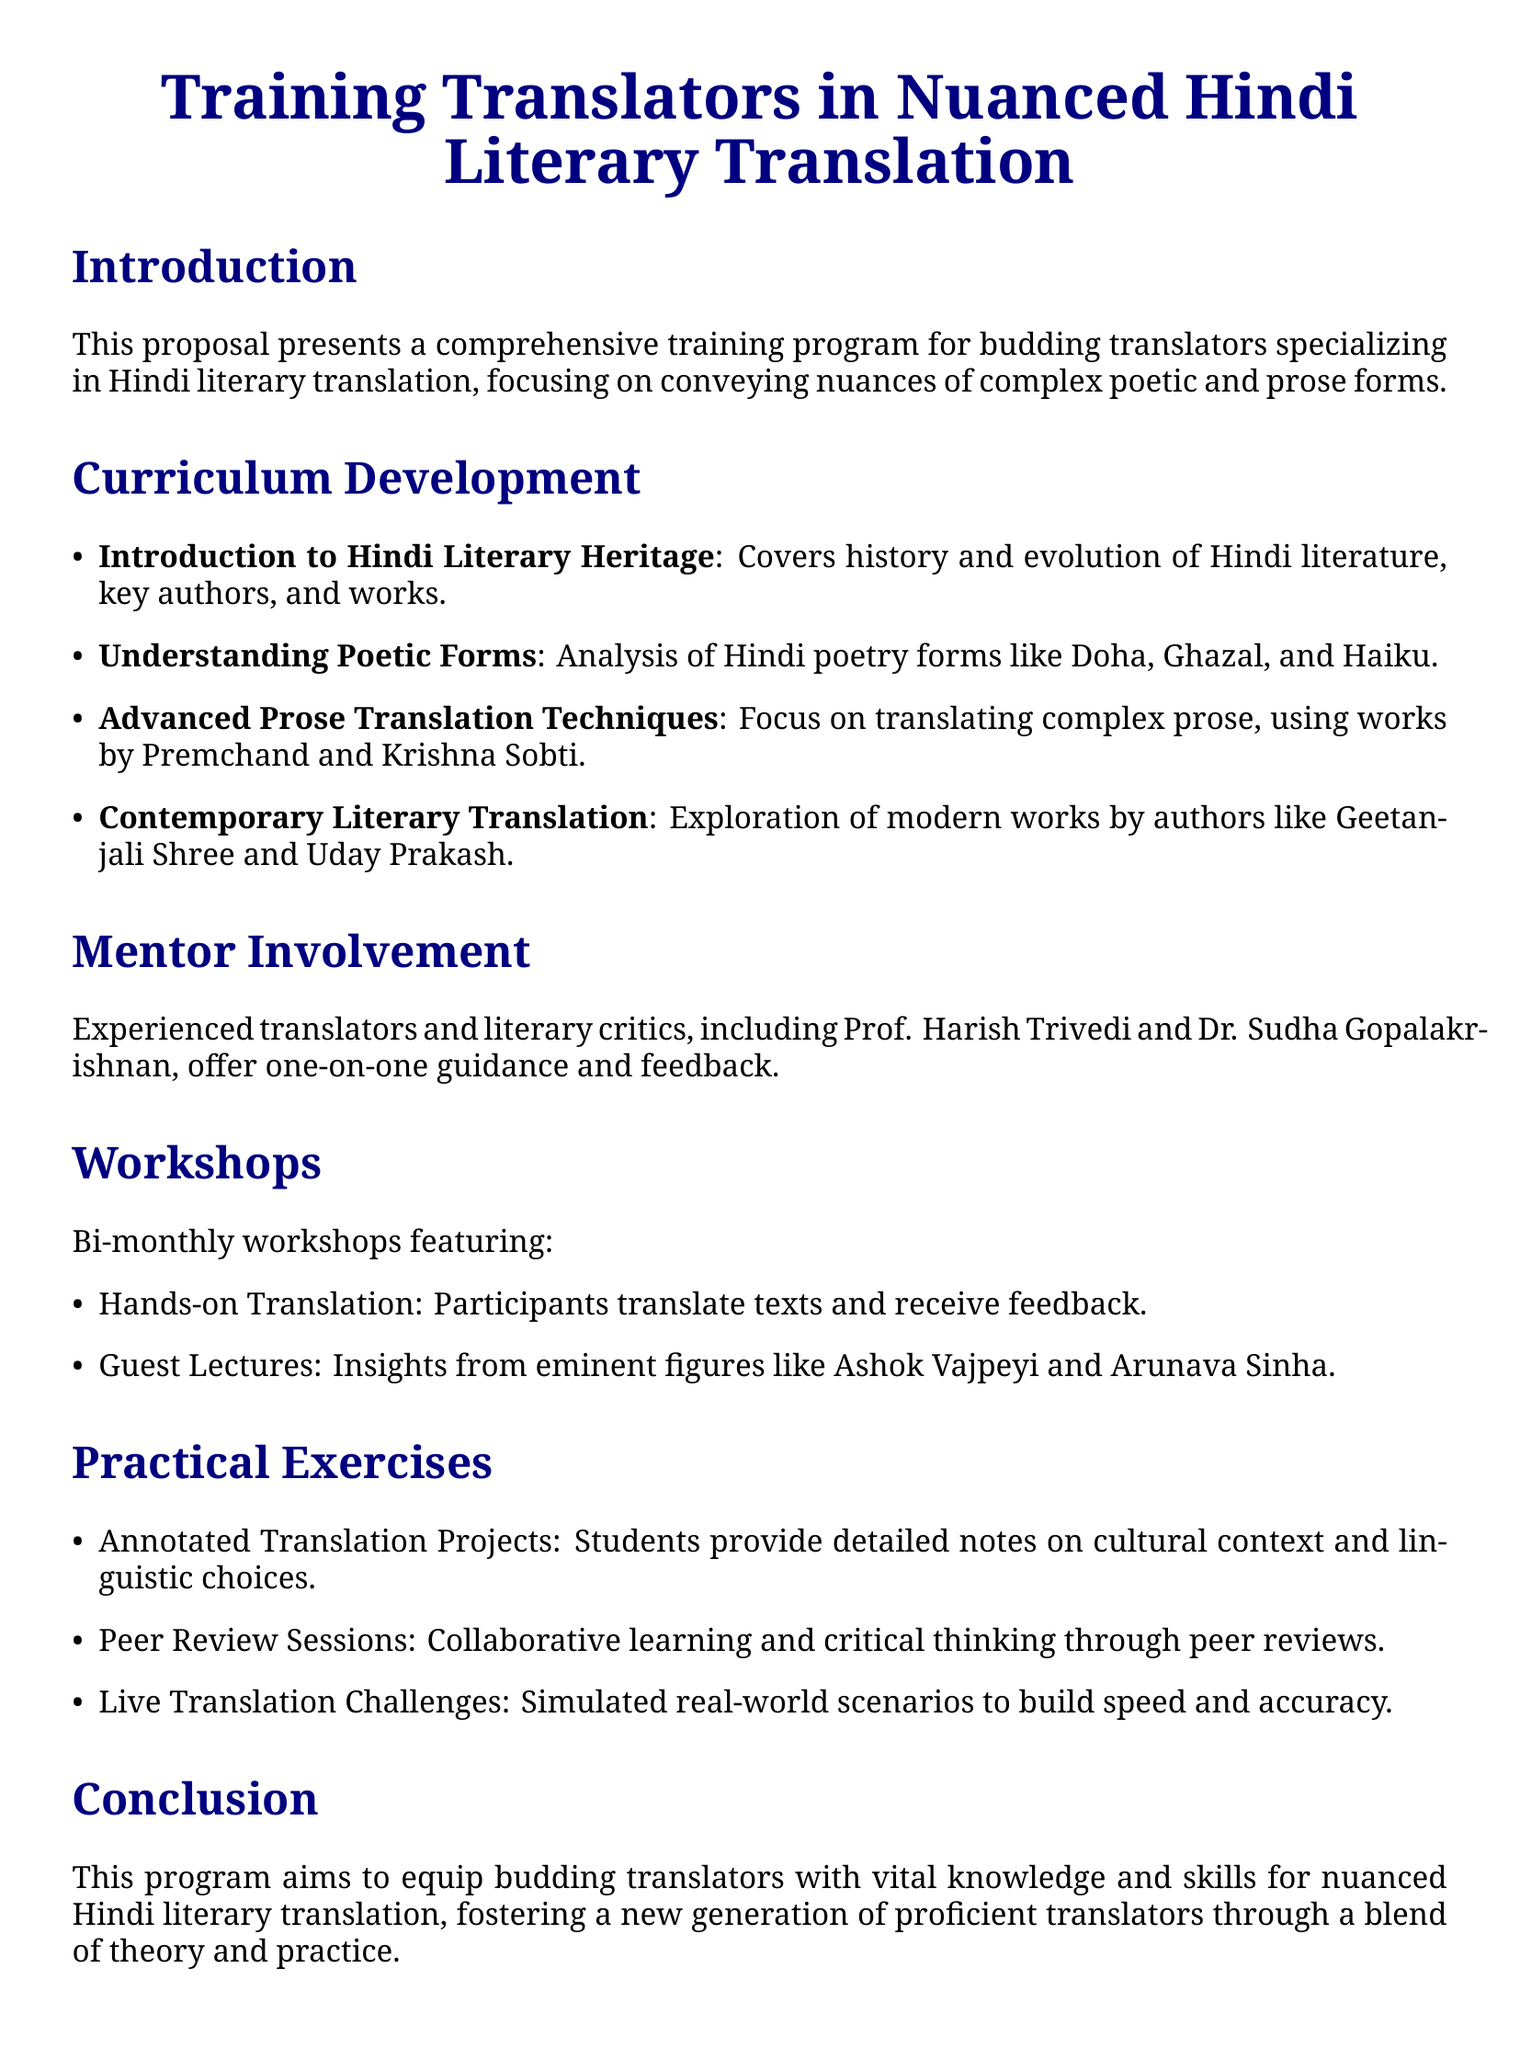What is the title of the proposal? The title of the proposal is explicitly stated at the beginning of the document.
Answer: Training Translators in Nuanced Hindi Literary Translation Who offers guidance in the mentor section? The document lists experienced translators and critics who provide mentorship.
Answer: Prof. Harish Trivedi and Dr. Sudha Gopalakrishnan What genre of works will participants analyze in the curriculum? The curriculum focuses on specific types of literature for translation.
Answer: Hindi poetry and prose How often are the workshops held? The document specifies the frequency of the workshops as outlined in the workshops section.
Answer: Bi-monthly What is one type of practical exercise mentioned? The document describes various exercises designed for practical training.
Answer: Annotated Translation Projects Which modern authors are explored in the curriculum? The proposal lists contemporary authors whose works will be studied.
Answer: Geetanjali Shree and Uday Prakash What is the goal of the training program? The conclusion summarizes the overall aim of the proposal.
Answer: Equip budding translators What is emphasized in the "Advanced Prose Translation Techniques"? The curriculum detail reveals a focus area within the literary translation.
Answer: Complex prose What type of feedback is provided during the workshops? The document states the type of feedback participants receive through practical sessions.
Answer: Feedback on translated texts 